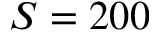<formula> <loc_0><loc_0><loc_500><loc_500>S = 2 0 0</formula> 